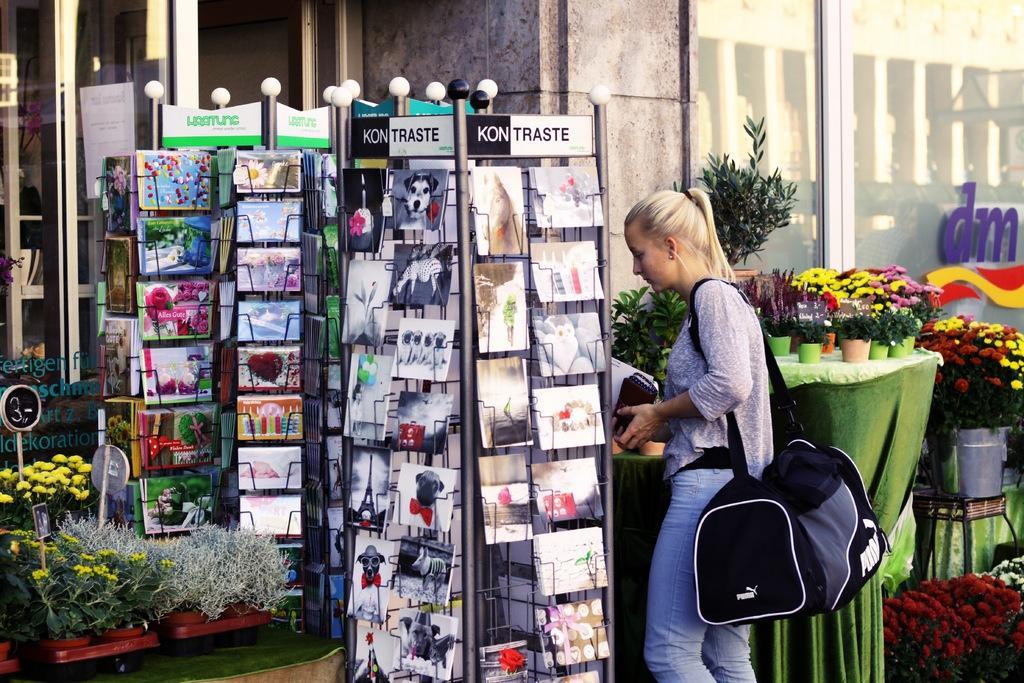Describe this image in one or two sentences. In this image on the right side there is one woman who is standing and she is wearing a bag and on the right side there are flower pots, plants and flowers are there and on the top of the right corner there is one window and in the middle of the image there is one wall and on the left side there are some books and in the bottom of the left corner there are some flower pots, plants and flowers are there and on the top of the left corner there is one glass window. 